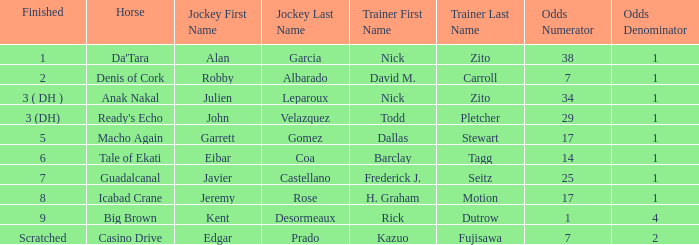What is the completed position for da'tara trained by nick zito? 1.0. 